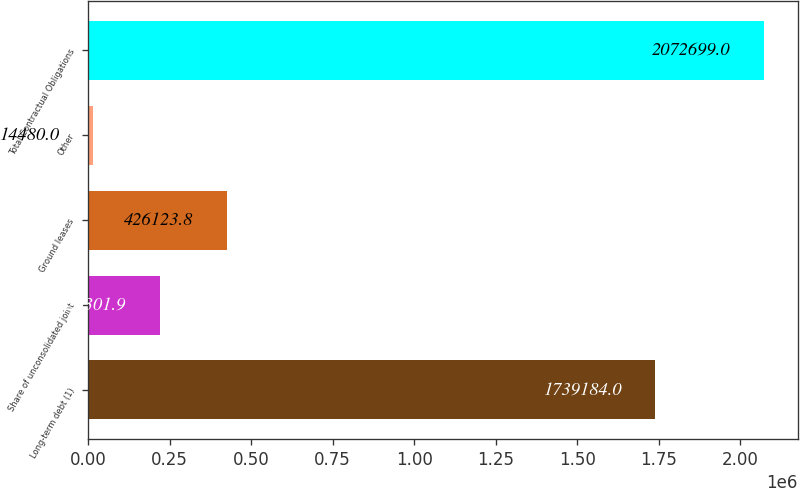Convert chart to OTSL. <chart><loc_0><loc_0><loc_500><loc_500><bar_chart><fcel>Long-term debt (1)<fcel>Share of unconsolidated joint<fcel>Ground leases<fcel>Other<fcel>Total Contractual Obligations<nl><fcel>1.73918e+06<fcel>220302<fcel>426124<fcel>14480<fcel>2.0727e+06<nl></chart> 